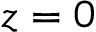<formula> <loc_0><loc_0><loc_500><loc_500>z = 0</formula> 